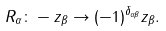Convert formula to latex. <formula><loc_0><loc_0><loc_500><loc_500>R _ { \alpha } \colon - z _ { \beta } \rightarrow ( - 1 ) ^ { \delta _ { \alpha \beta } } z _ { \beta } .</formula> 